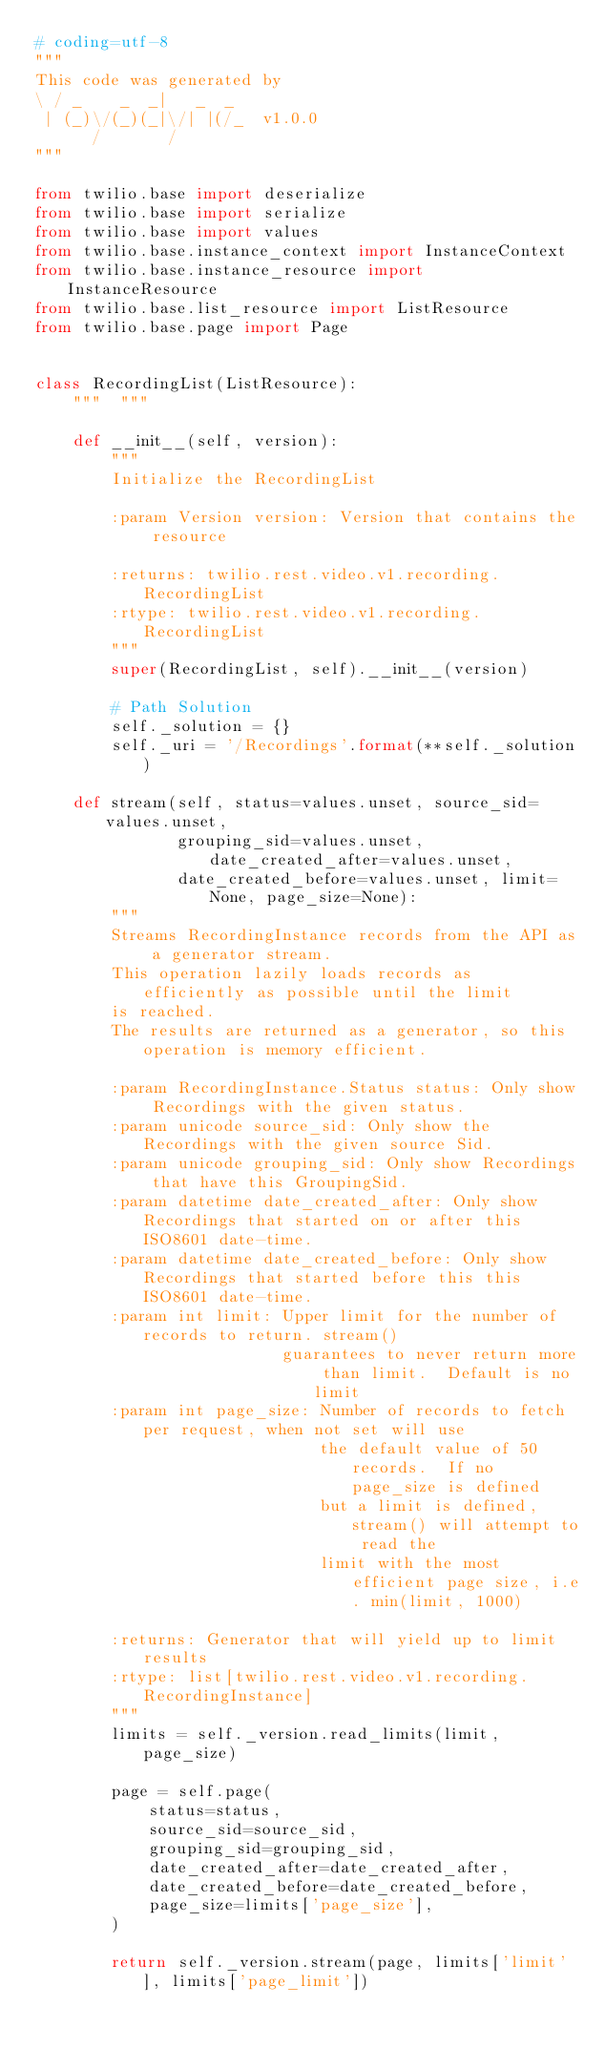<code> <loc_0><loc_0><loc_500><loc_500><_Python_># coding=utf-8
"""
This code was generated by
\ / _    _  _|   _  _
 | (_)\/(_)(_|\/| |(/_  v1.0.0
      /       /
"""

from twilio.base import deserialize
from twilio.base import serialize
from twilio.base import values
from twilio.base.instance_context import InstanceContext
from twilio.base.instance_resource import InstanceResource
from twilio.base.list_resource import ListResource
from twilio.base.page import Page


class RecordingList(ListResource):
    """  """

    def __init__(self, version):
        """
        Initialize the RecordingList

        :param Version version: Version that contains the resource

        :returns: twilio.rest.video.v1.recording.RecordingList
        :rtype: twilio.rest.video.v1.recording.RecordingList
        """
        super(RecordingList, self).__init__(version)

        # Path Solution
        self._solution = {}
        self._uri = '/Recordings'.format(**self._solution)

    def stream(self, status=values.unset, source_sid=values.unset,
               grouping_sid=values.unset, date_created_after=values.unset,
               date_created_before=values.unset, limit=None, page_size=None):
        """
        Streams RecordingInstance records from the API as a generator stream.
        This operation lazily loads records as efficiently as possible until the limit
        is reached.
        The results are returned as a generator, so this operation is memory efficient.

        :param RecordingInstance.Status status: Only show Recordings with the given status.
        :param unicode source_sid: Only show the Recordings with the given source Sid.
        :param unicode grouping_sid: Only show Recordings that have this GroupingSid.
        :param datetime date_created_after: Only show Recordings that started on or after this ISO8601 date-time.
        :param datetime date_created_before: Only show Recordings that started before this this ISO8601 date-time.
        :param int limit: Upper limit for the number of records to return. stream()
                          guarantees to never return more than limit.  Default is no limit
        :param int page_size: Number of records to fetch per request, when not set will use
                              the default value of 50 records.  If no page_size is defined
                              but a limit is defined, stream() will attempt to read the
                              limit with the most efficient page size, i.e. min(limit, 1000)

        :returns: Generator that will yield up to limit results
        :rtype: list[twilio.rest.video.v1.recording.RecordingInstance]
        """
        limits = self._version.read_limits(limit, page_size)

        page = self.page(
            status=status,
            source_sid=source_sid,
            grouping_sid=grouping_sid,
            date_created_after=date_created_after,
            date_created_before=date_created_before,
            page_size=limits['page_size'],
        )

        return self._version.stream(page, limits['limit'], limits['page_limit'])
</code> 